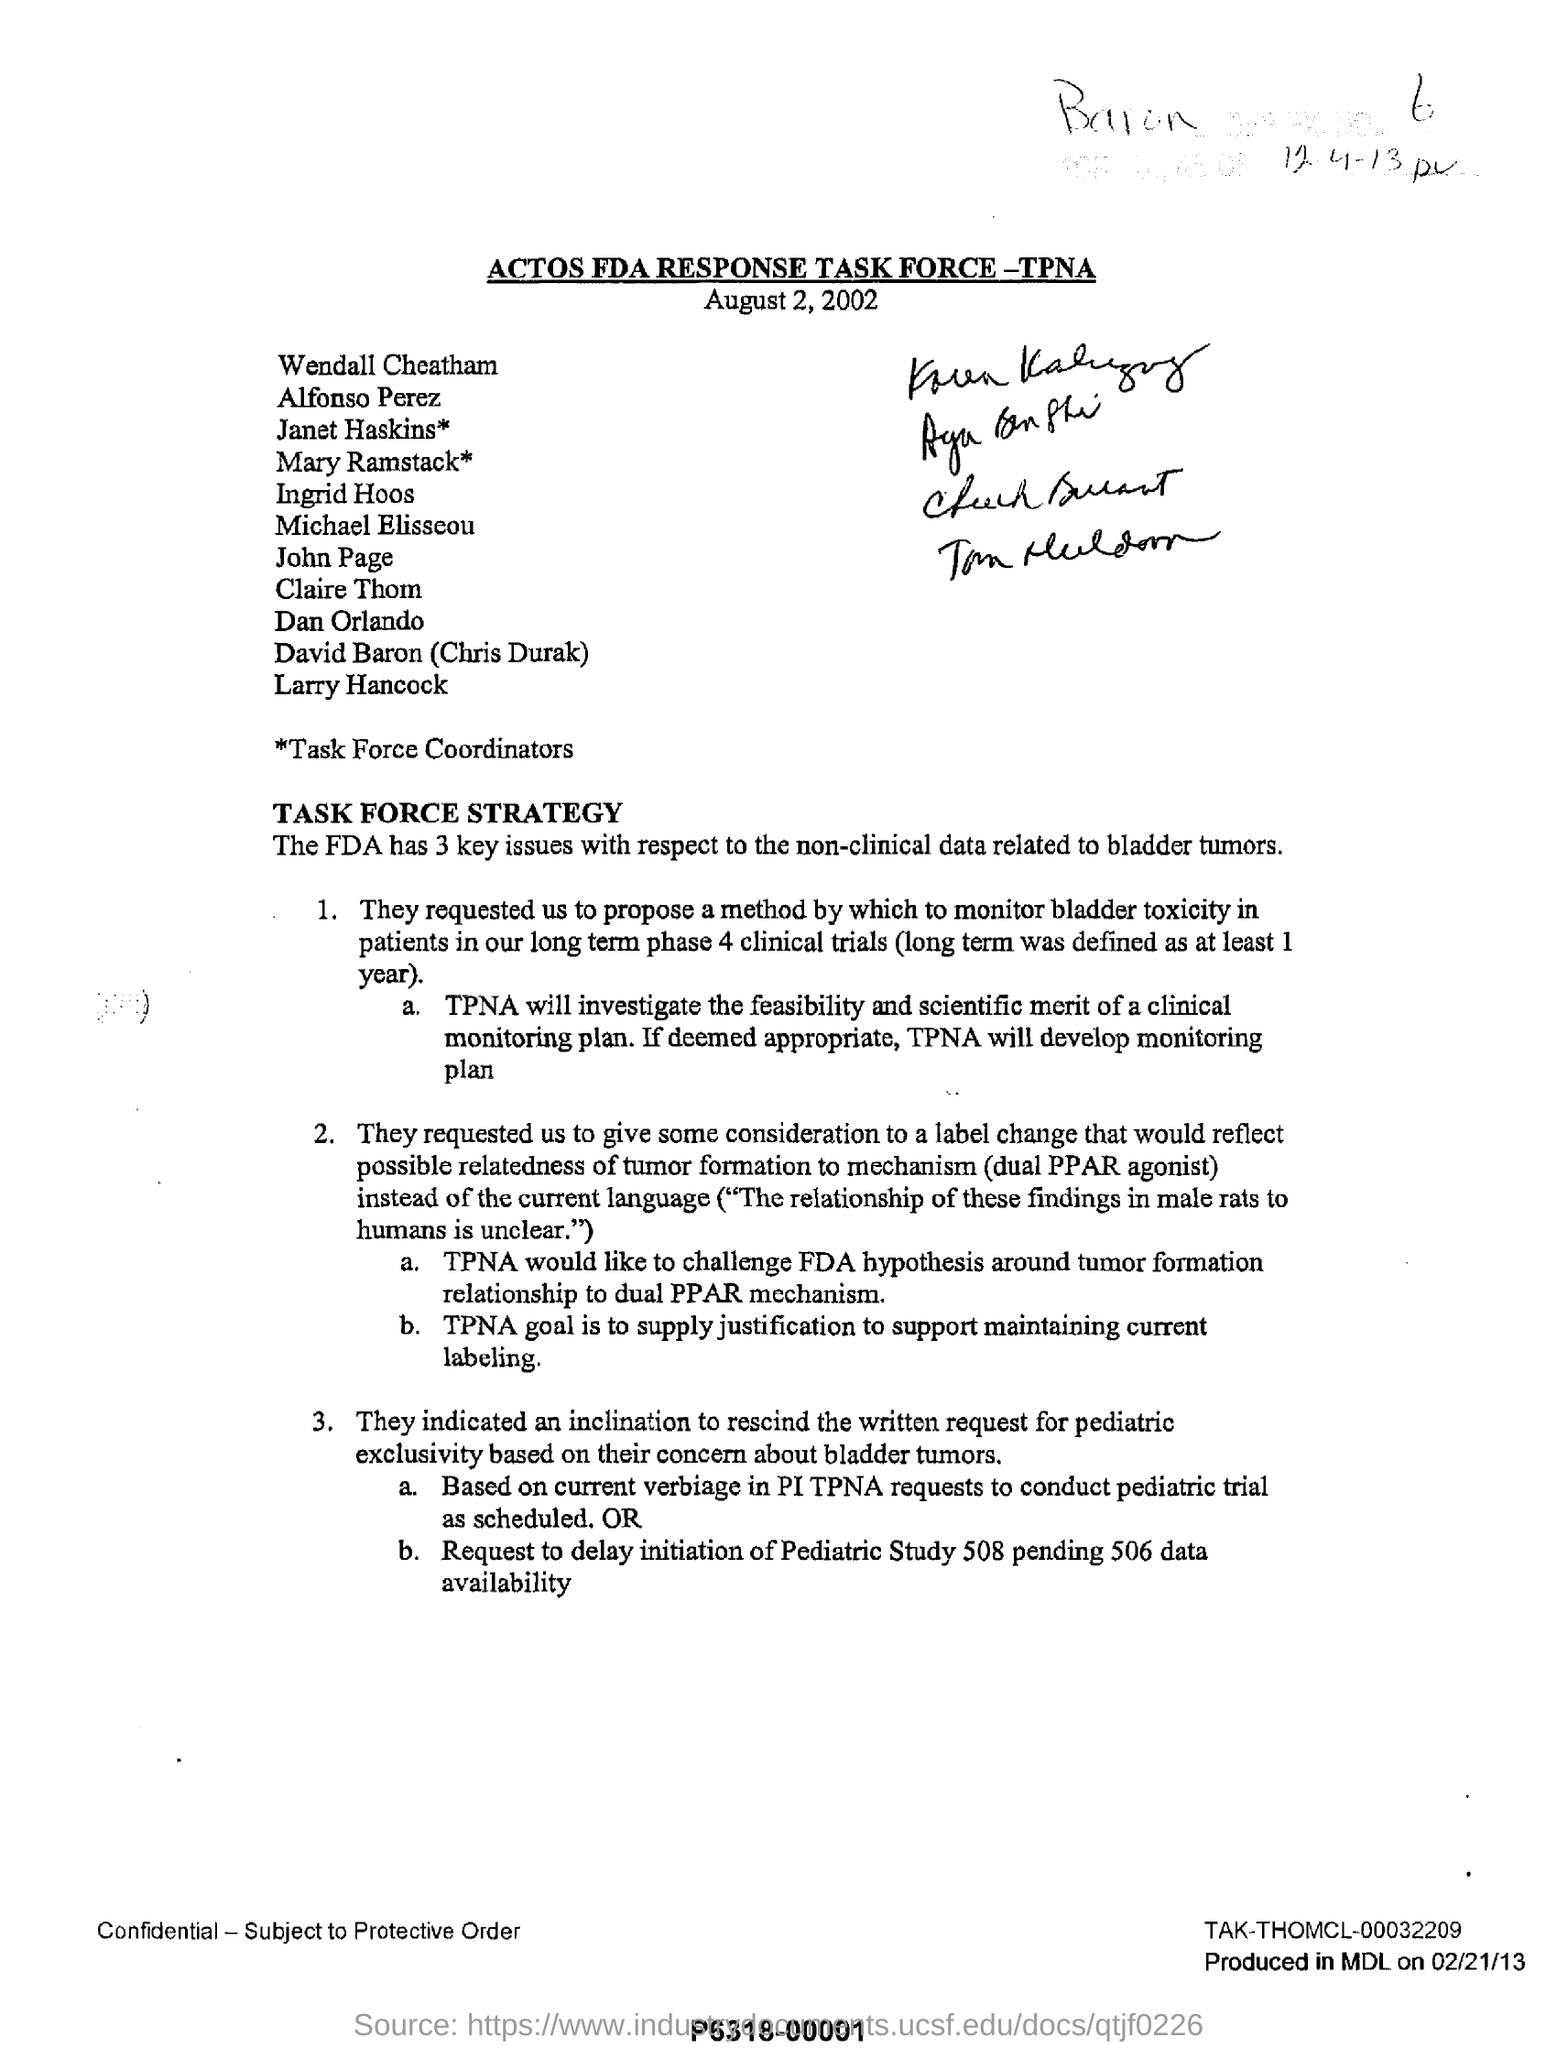What is the heading of the document?
Provide a short and direct response. ACTOS FDA RESPONSE TASK FORCE-TPNA. How many key issues does the FDA have with respect to the non-clinical data related to bladder tumors?
Your answer should be compact. The FDA has 3 key issues with respect to the non-clinical data related to bladder tumors. What plan is developed by TPNA?
Provide a short and direct response. TPNA will develop monitoring plan. What is TPNA's goal?
Ensure brevity in your answer.  Is to supply justification to support maintaining current labeling. 